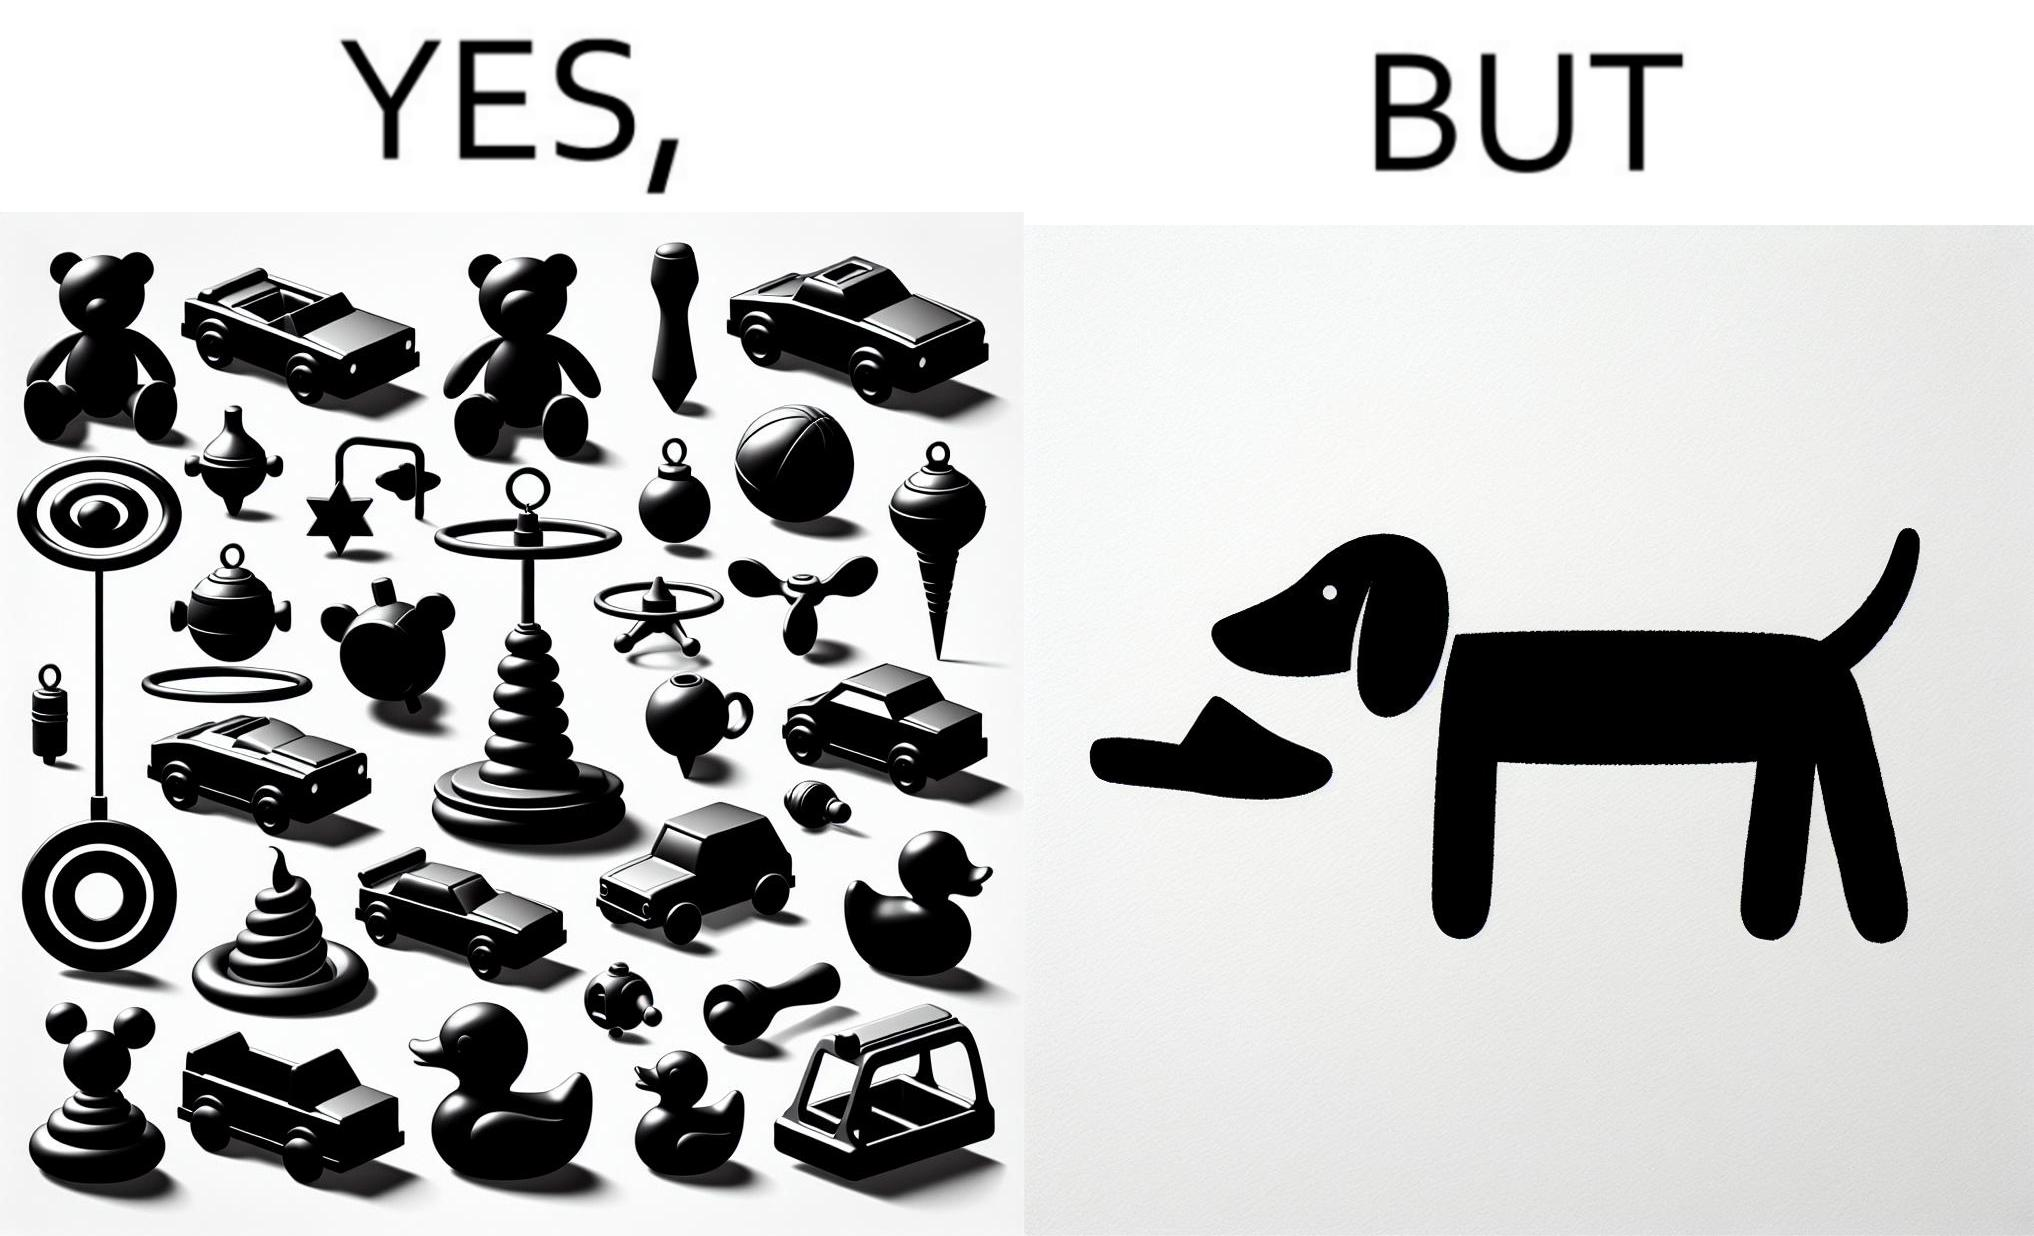Describe what you see in the left and right parts of this image. In the left part of the image: a bunch of toys In the right part of the image: a dog holding a slipper 